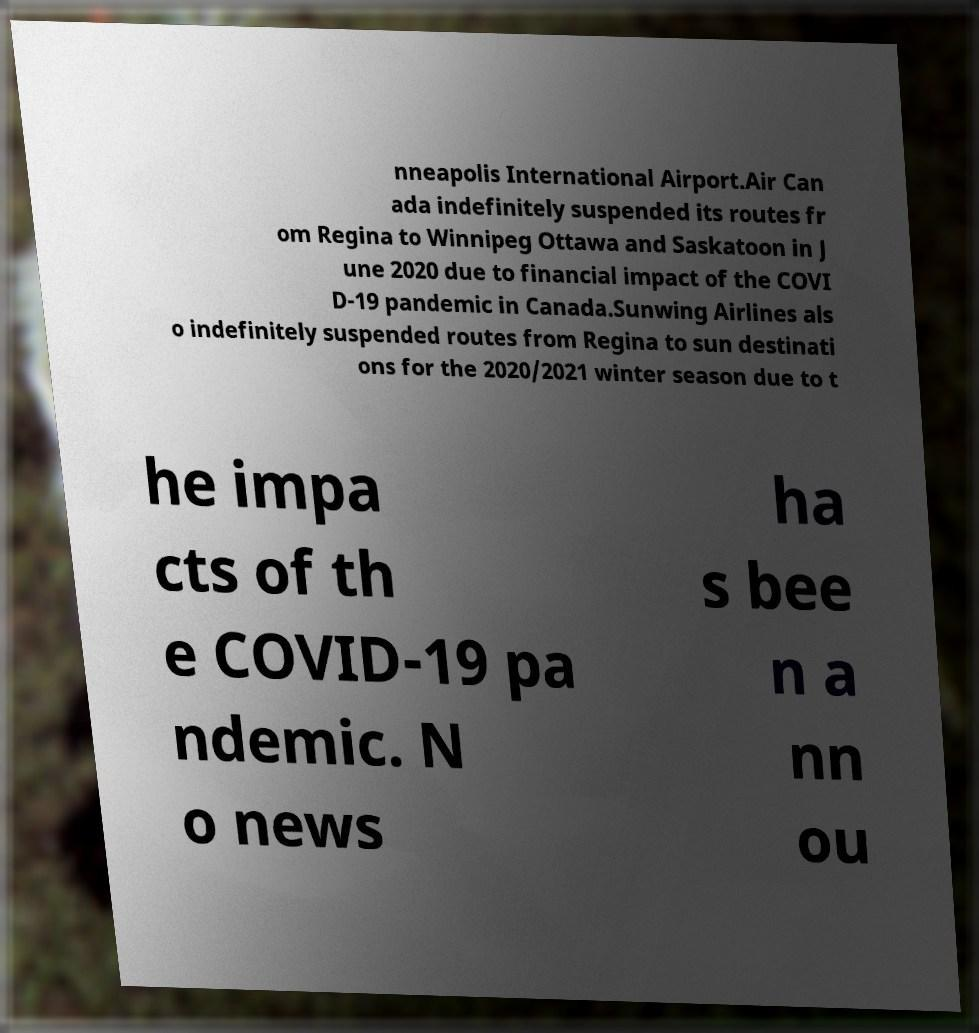There's text embedded in this image that I need extracted. Can you transcribe it verbatim? nneapolis International Airport.Air Can ada indefinitely suspended its routes fr om Regina to Winnipeg Ottawa and Saskatoon in J une 2020 due to financial impact of the COVI D-19 pandemic in Canada.Sunwing Airlines als o indefinitely suspended routes from Regina to sun destinati ons for the 2020/2021 winter season due to t he impa cts of th e COVID-19 pa ndemic. N o news ha s bee n a nn ou 